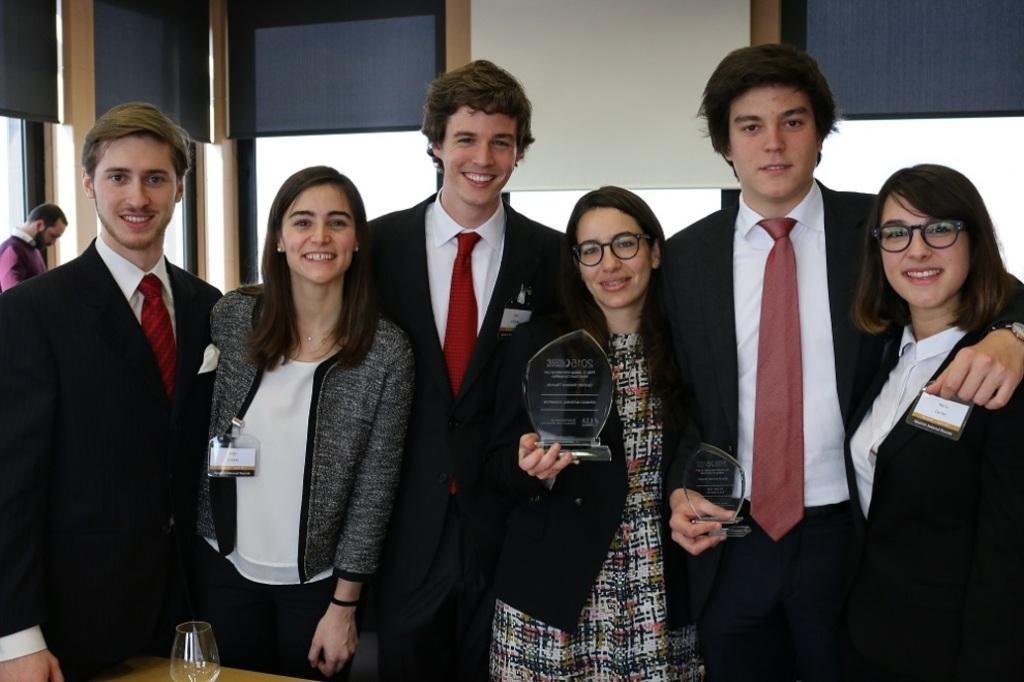In one or two sentences, can you explain what this image depicts? Here we can see few persons are standing on the floor and they are smiling. There is a glass on a platform. 